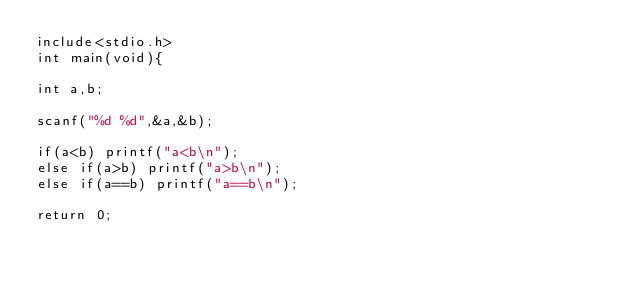Convert code to text. <code><loc_0><loc_0><loc_500><loc_500><_C_>include<stdio.h>
int main(void){

int a,b;

scanf("%d %d",&a,&b);

if(a<b) printf("a<b\n");
else if(a>b) printf("a>b\n");
else if(a==b) printf("a==b\n");

return 0;</code> 